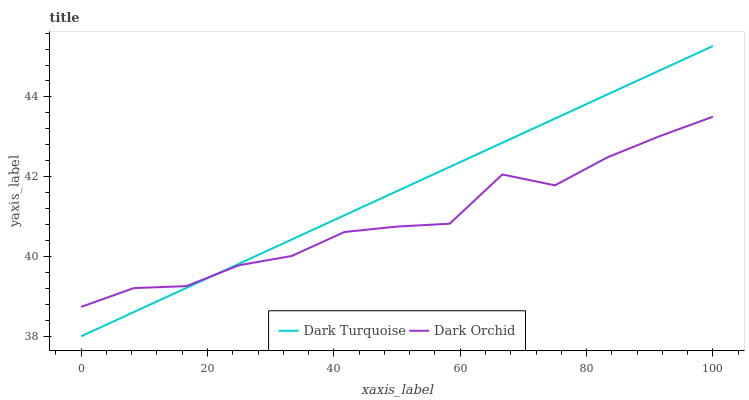Does Dark Orchid have the maximum area under the curve?
Answer yes or no. No. Is Dark Orchid the smoothest?
Answer yes or no. No. Does Dark Orchid have the lowest value?
Answer yes or no. No. Does Dark Orchid have the highest value?
Answer yes or no. No. 